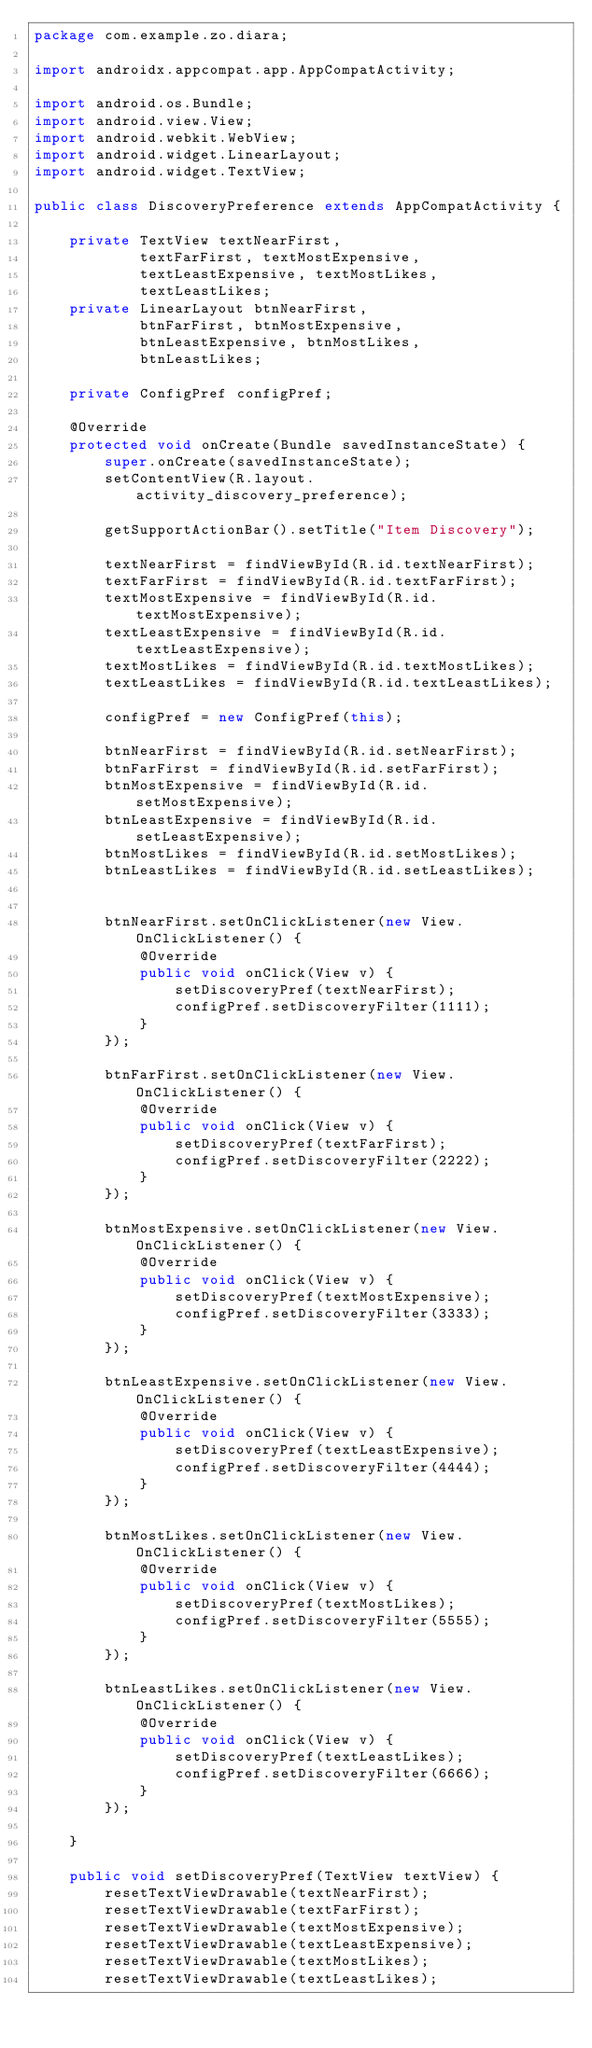<code> <loc_0><loc_0><loc_500><loc_500><_Java_>package com.example.zo.diara;

import androidx.appcompat.app.AppCompatActivity;

import android.os.Bundle;
import android.view.View;
import android.webkit.WebView;
import android.widget.LinearLayout;
import android.widget.TextView;

public class DiscoveryPreference extends AppCompatActivity {

    private TextView textNearFirst,
            textFarFirst, textMostExpensive,
            textLeastExpensive, textMostLikes,
            textLeastLikes;
    private LinearLayout btnNearFirst,
            btnFarFirst, btnMostExpensive,
            btnLeastExpensive, btnMostLikes,
            btnLeastLikes;

    private ConfigPref configPref;

    @Override
    protected void onCreate(Bundle savedInstanceState) {
        super.onCreate(savedInstanceState);
        setContentView(R.layout.activity_discovery_preference);

        getSupportActionBar().setTitle("Item Discovery");

        textNearFirst = findViewById(R.id.textNearFirst);
        textFarFirst = findViewById(R.id.textFarFirst);
        textMostExpensive = findViewById(R.id.textMostExpensive);
        textLeastExpensive = findViewById(R.id.textLeastExpensive);
        textMostLikes = findViewById(R.id.textMostLikes);
        textLeastLikes = findViewById(R.id.textLeastLikes);

        configPref = new ConfigPref(this);

        btnNearFirst = findViewById(R.id.setNearFirst);
        btnFarFirst = findViewById(R.id.setFarFirst);
        btnMostExpensive = findViewById(R.id.setMostExpensive);
        btnLeastExpensive = findViewById(R.id.setLeastExpensive);
        btnMostLikes = findViewById(R.id.setMostLikes);
        btnLeastLikes = findViewById(R.id.setLeastLikes);


        btnNearFirst.setOnClickListener(new View.OnClickListener() {
            @Override
            public void onClick(View v) {
                setDiscoveryPref(textNearFirst);
                configPref.setDiscoveryFilter(1111);
            }
        });

        btnFarFirst.setOnClickListener(new View.OnClickListener() {
            @Override
            public void onClick(View v) {
                setDiscoveryPref(textFarFirst);
                configPref.setDiscoveryFilter(2222);
            }
        });

        btnMostExpensive.setOnClickListener(new View.OnClickListener() {
            @Override
            public void onClick(View v) {
                setDiscoveryPref(textMostExpensive);
                configPref.setDiscoveryFilter(3333);
            }
        });

        btnLeastExpensive.setOnClickListener(new View.OnClickListener() {
            @Override
            public void onClick(View v) {
                setDiscoveryPref(textLeastExpensive);
                configPref.setDiscoveryFilter(4444);
            }
        });

        btnMostLikes.setOnClickListener(new View.OnClickListener() {
            @Override
            public void onClick(View v) {
                setDiscoveryPref(textMostLikes);
                configPref.setDiscoveryFilter(5555);
            }
        });

        btnLeastLikes.setOnClickListener(new View.OnClickListener() {
            @Override
            public void onClick(View v) {
                setDiscoveryPref(textLeastLikes);
                configPref.setDiscoveryFilter(6666);
            }
        });

    }

    public void setDiscoveryPref(TextView textView) {
        resetTextViewDrawable(textNearFirst);
        resetTextViewDrawable(textFarFirst);
        resetTextViewDrawable(textMostExpensive);
        resetTextViewDrawable(textLeastExpensive);
        resetTextViewDrawable(textMostLikes);
        resetTextViewDrawable(textLeastLikes);</code> 